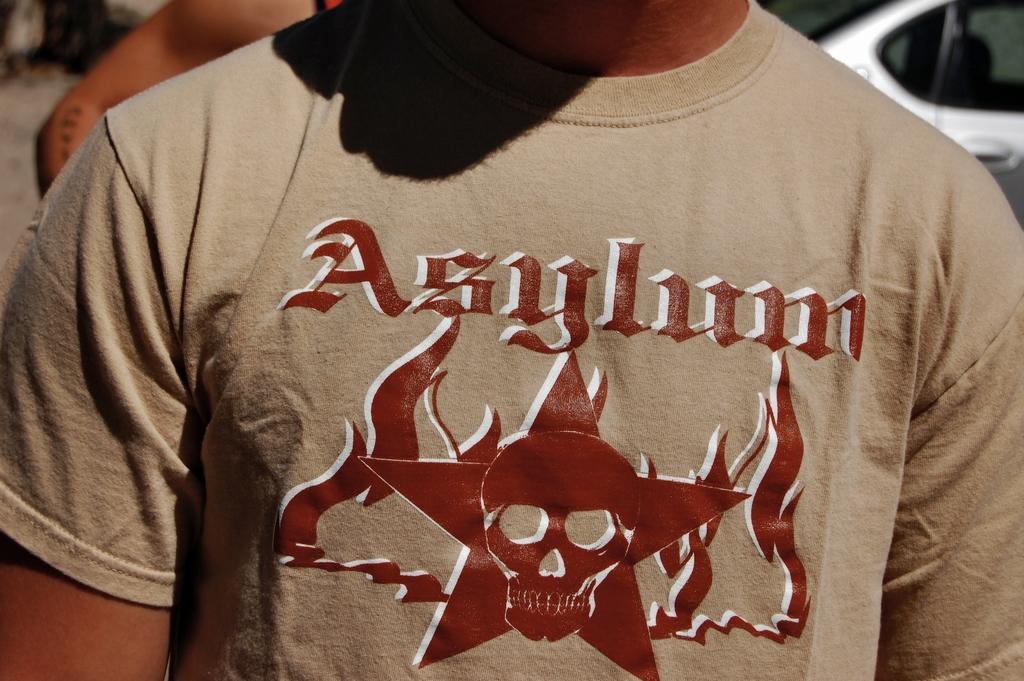What does his shirt say?
Give a very brief answer. Asylum. What brand name is on this man's shirt?
Your response must be concise. Asylum. 